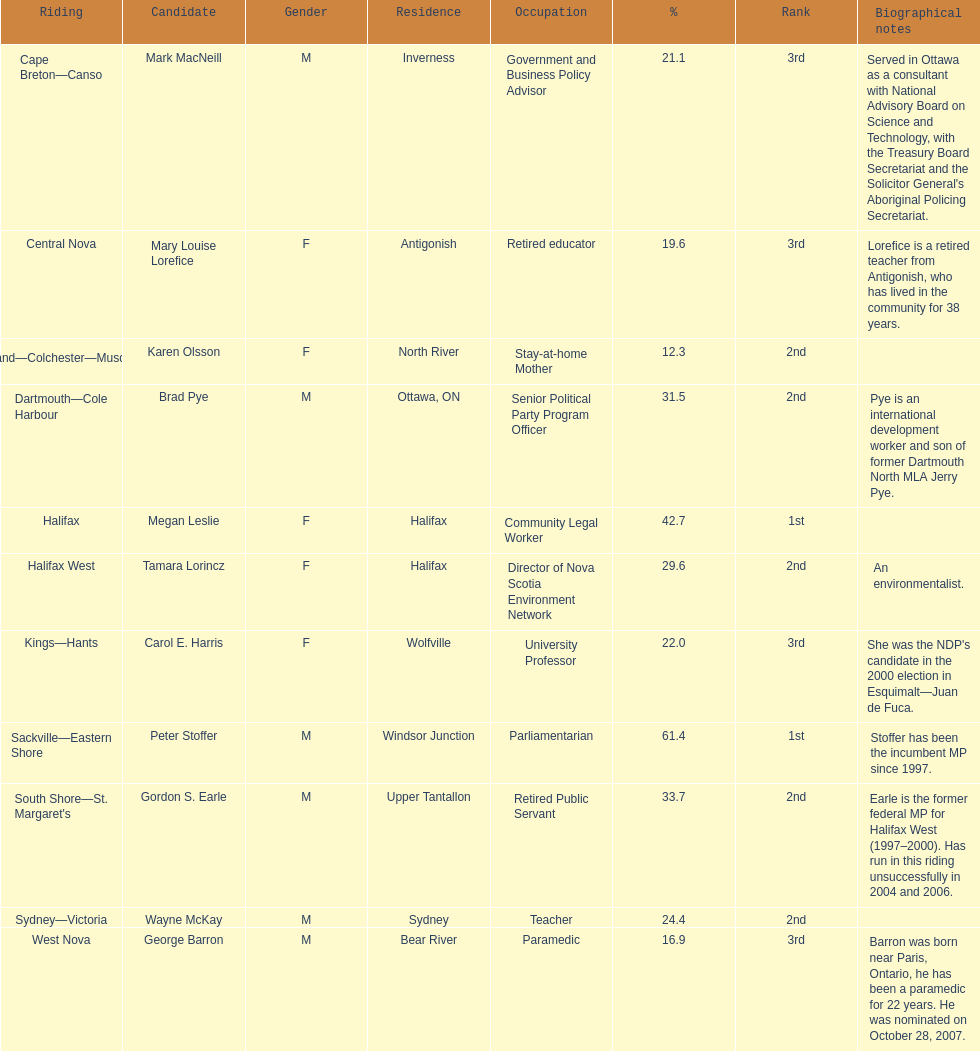Who has the most votes? Sackville-Eastern Shore. 